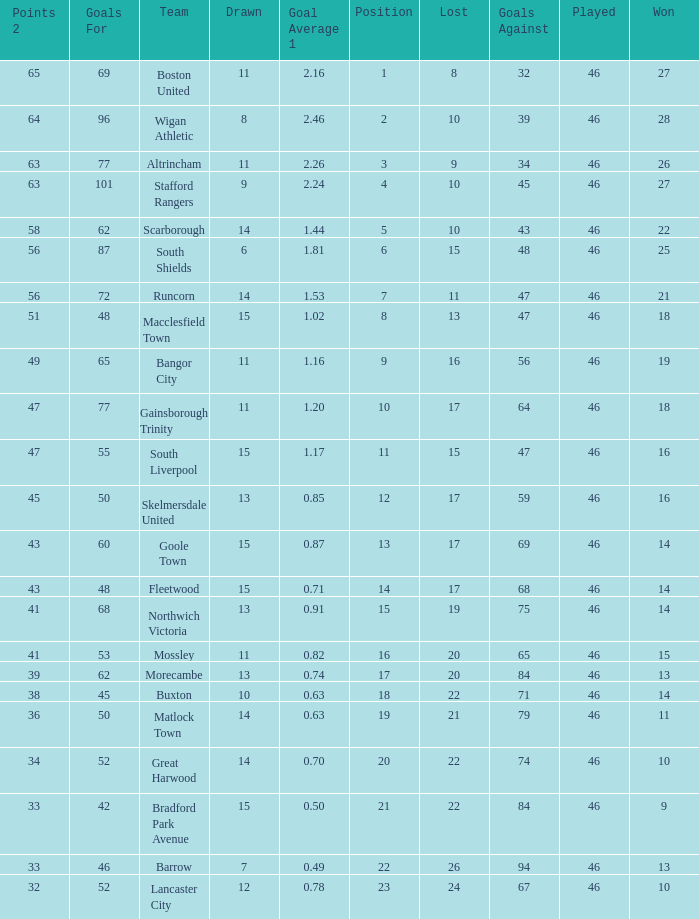How many games did the team who scored 60 goals win? 14.0. 